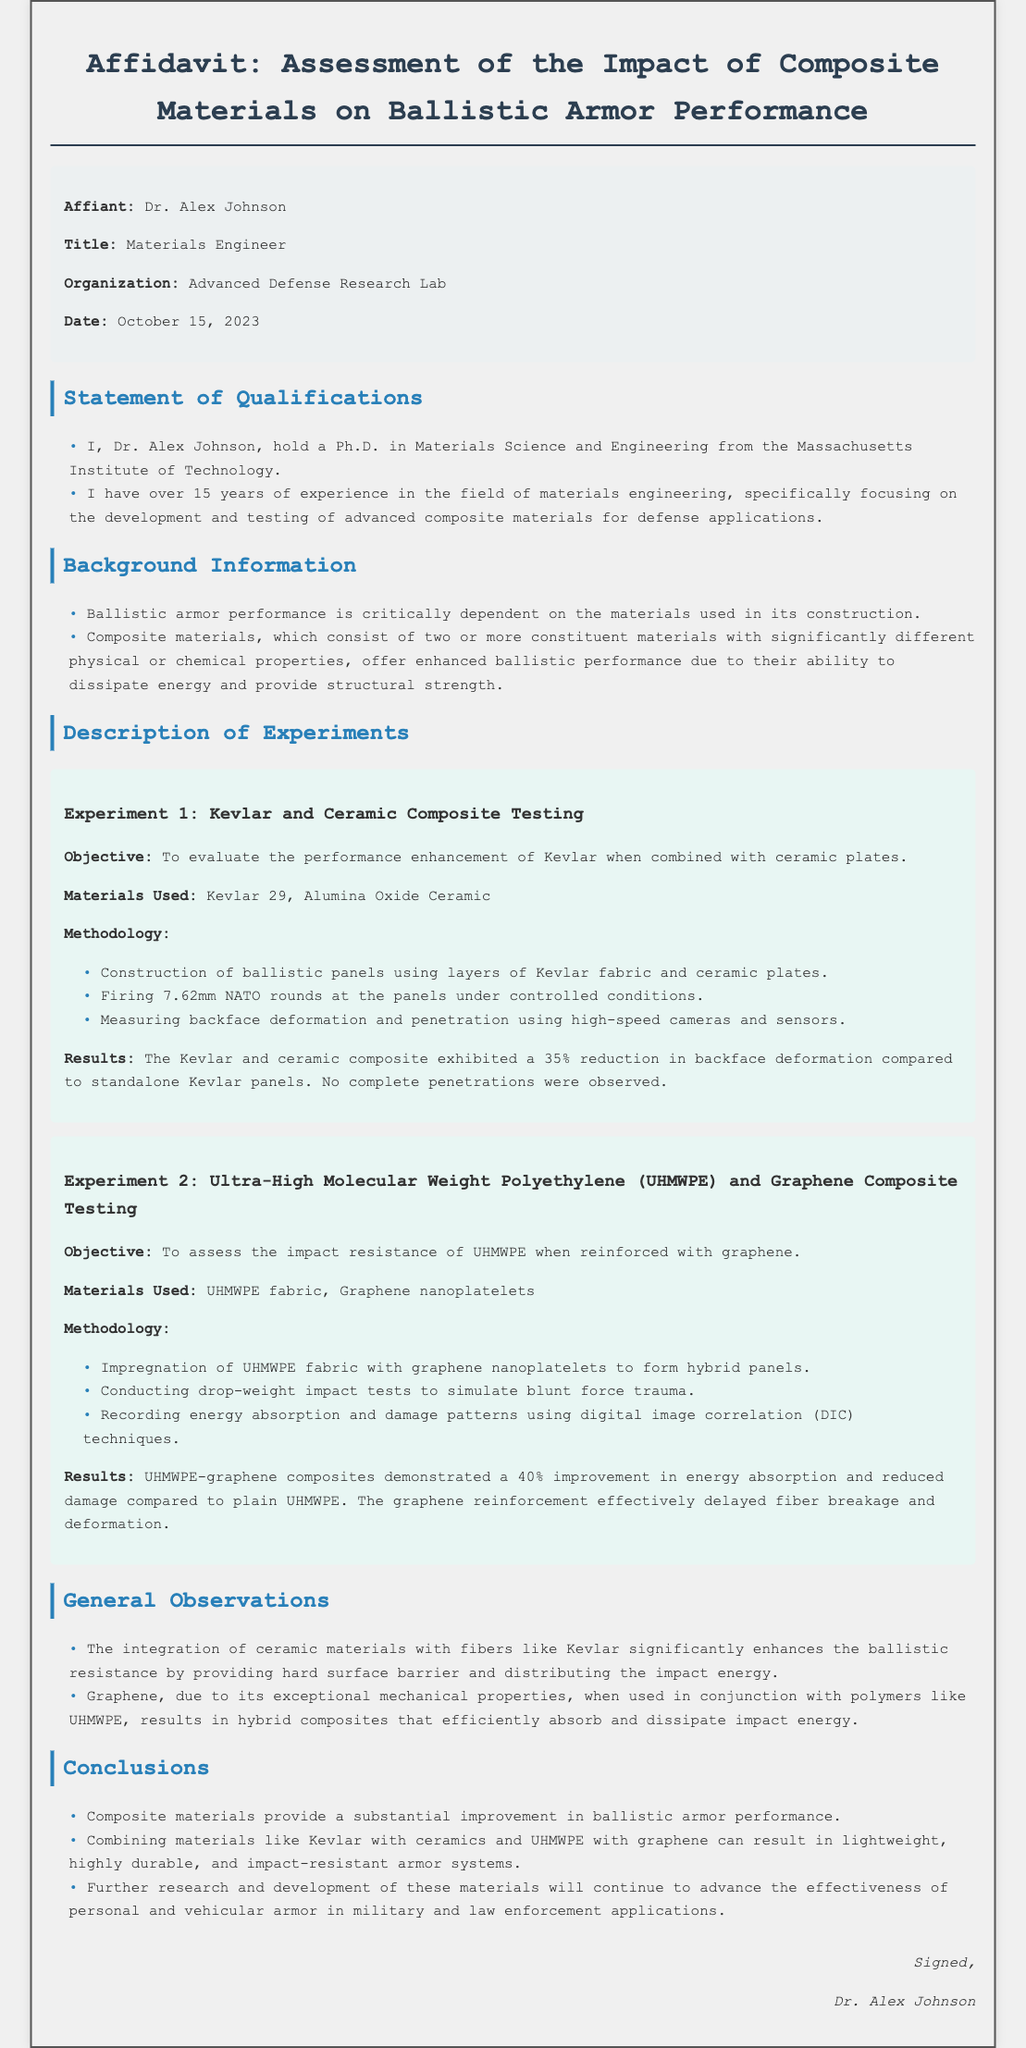What is the name of the affiant? The name of the affiant is mentioned in the document as Dr. Alex Johnson.
Answer: Dr. Alex Johnson What is the date of the affidavit? The date provided in the affidavit is October 15, 2023.
Answer: October 15, 2023 What materials were used in Experiment 1? The materials used in Experiment 1 include Kevlar 29 and Alumina Oxide Ceramic.
Answer: Kevlar 29, Alumina Oxide Ceramic What percentage reduction in backface deformation was observed in Experiment 1? The document states that there was a 35% reduction in backface deformation compared to standalone Kevlar panels.
Answer: 35% What was the improvement percentage in energy absorption for the UHMWPE-graphene composites? The UHMWPE-graphene composites demonstrated a 40% improvement in energy absorption compared to plain UHMWPE.
Answer: 40% What is the primary function of composite materials in ballistic armor? The primary function is to enhance ballistic performance by dissipating energy and providing structural strength.
Answer: Enhance ballistic performance What unique property of graphene is highlighted in the document? The document highlights graphene's exceptional mechanical properties, which contribute to improved armor performance.
Answer: Exceptional mechanical properties What type of testing was conducted for UHMWPE and graphene composites? The testing conducted involved drop-weight impact tests to simulate blunt force trauma.
Answer: Drop-weight impact tests Who is the organizational affiliation of the affiant? The affiant's organizational affiliation is the Advanced Defense Research Lab.
Answer: Advanced Defense Research Lab 